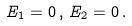<formula> <loc_0><loc_0><loc_500><loc_500>E _ { 1 } = 0 \, , \, E _ { 2 } = 0 \, .</formula> 